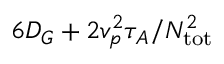<formula> <loc_0><loc_0><loc_500><loc_500>6 D _ { G } + 2 v _ { p } ^ { 2 } \tau _ { A } / N _ { t o t } ^ { 2 }</formula> 